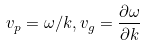<formula> <loc_0><loc_0><loc_500><loc_500>v _ { p } = \omega / k , v _ { g } = \frac { \partial \omega } { \partial k }</formula> 